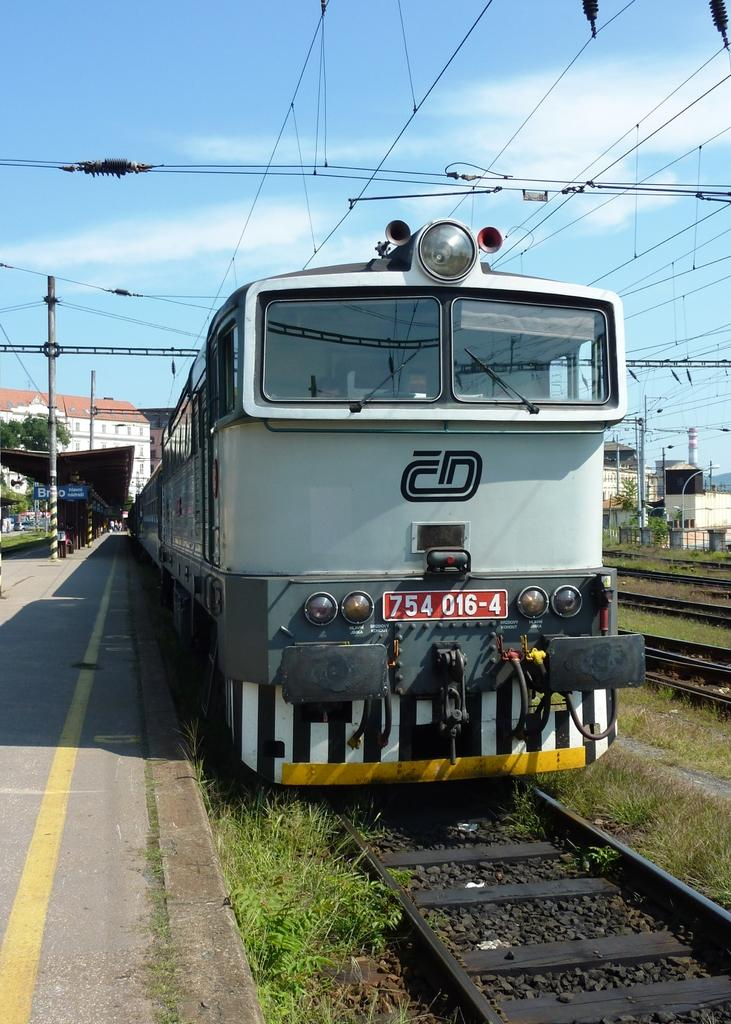What is the main subject of the image? The main subject of the image is a train. What can be observed about the train's position in the image? The train is on a track. What is the color of the train? The train is grey in color. What is located on the left side of the image? There is a platform with poles on the left side of the image. What is visible at the top of the image? The sky is visible at the top of the image, and there are wires present as well. Can you tell me how many aunts are standing near the train in the image? There are no aunts present in the image; it only features a train, a track, a platform with poles, the sky, and wires. What type of snack is being served on the train in the image? There is no indication of any snacks, including popcorn, being served on the train in the image. 